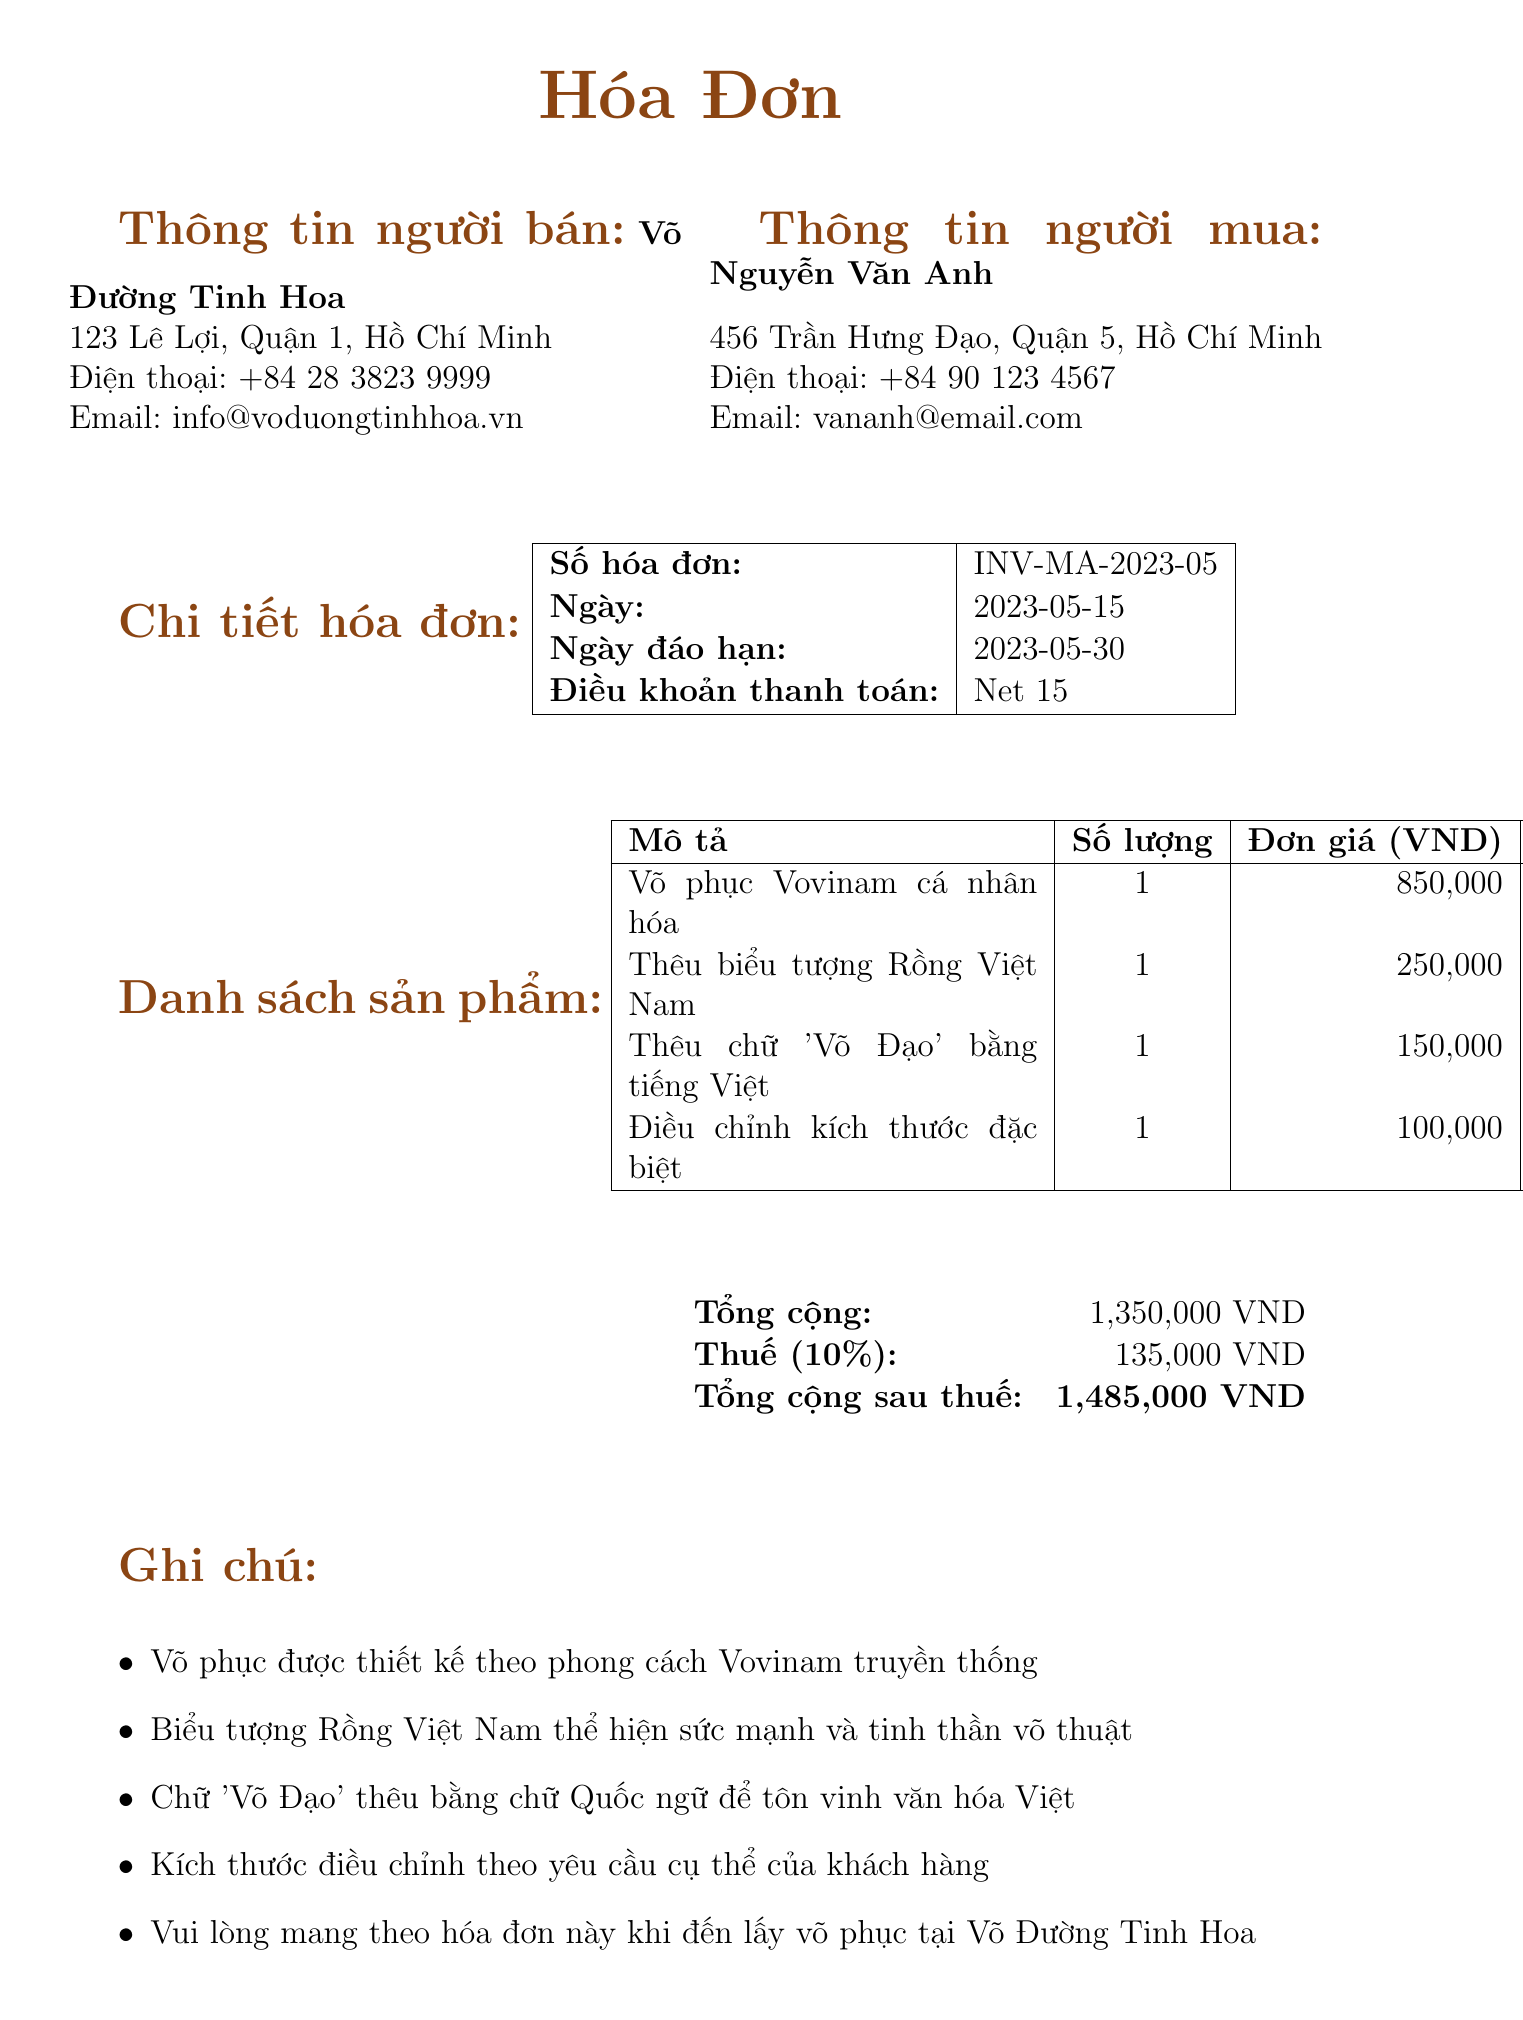what is the invoice number? The invoice number is listed at the top of the invoice, indicating its unique reference.
Answer: INV-MA-2023-05 who is the seller? The seller's name is given in the seller's information section of the document.
Answer: Võ Đường Tinh Hoa what is the total amount due? The total amount due is calculated at the bottom of the invoice, including all charges and tax.
Answer: 1,485,000 VND what is the tax rate applied? The tax rate is specified in the invoice details, reflecting the percentage of tax on the subtotal.
Answer: 10% which item has the highest unit price? The unit prices for each item are listed, indicating which item costs the most.
Answer: Võ phục Vovinam cá nhân hóa how many items are listed on the invoice? The number of items can be counted directly from the product list section of the invoice.
Answer: 4 what is the payment term? The payment terms indicate how long the buyer has to make the payment after the invoice date.
Answer: Net 15 what is the address of the buyer? The buyer's address is provided in the buyer’s information section.
Answer: 456 Trần Hưng Đạo, Quận 5, Hồ Chí Minh what methods of payment are accepted? The document lists the acceptable payment methods in a specified section.
Answer: Tiền mặt, Chuyển khoản ngân hàng, Ví điện tử MoMo 